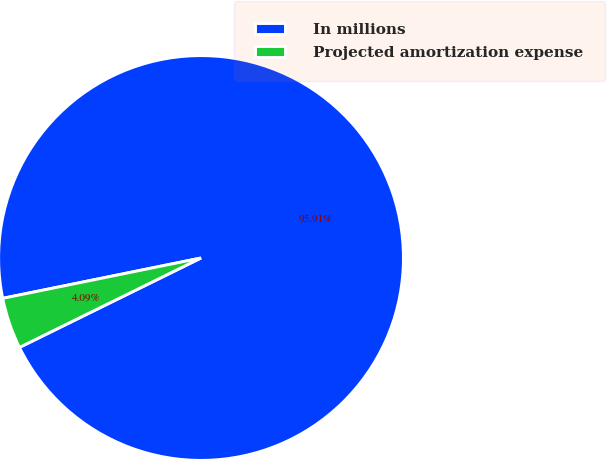Convert chart. <chart><loc_0><loc_0><loc_500><loc_500><pie_chart><fcel>In millions<fcel>Projected amortization expense<nl><fcel>95.91%<fcel>4.09%<nl></chart> 